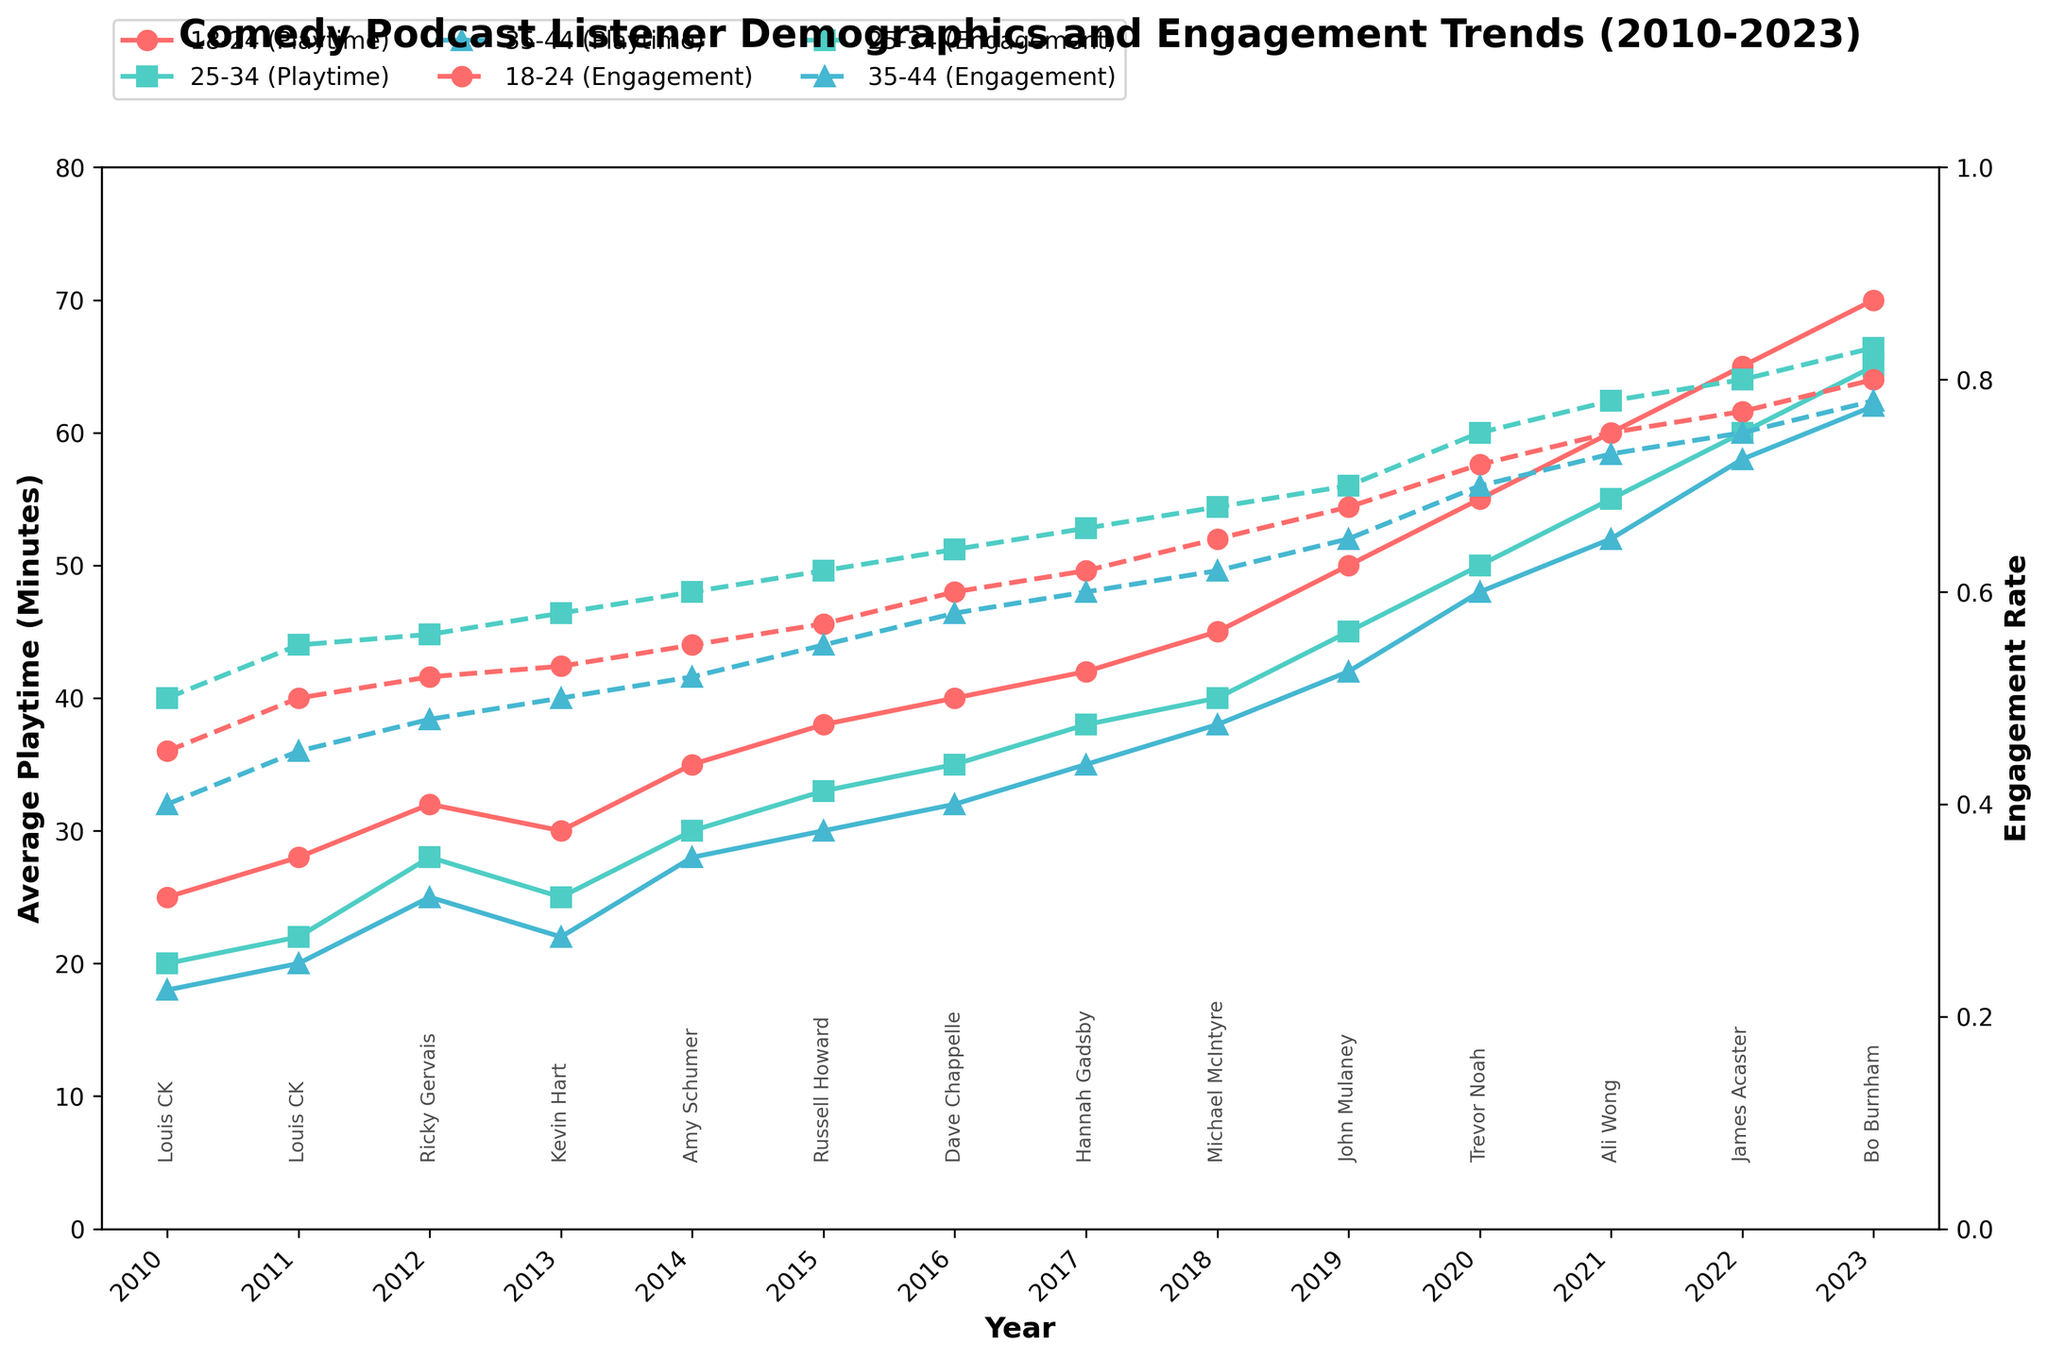What is the average playtime for the 18-24 age group in 2012? Refer to the plot and find the point corresponding to the 18-24 age group for the year 2012, which shows the average playtime as 32 minutes.
Answer: 32 minutes What is the title of the figure? The figure's title is displayed at the top center, which reads "Comedy Podcast Listener Demographics and Engagement Trends (2010-2023)".
Answer: Comedy Podcast Listener Demographics and Engagement Trends (2010-2023) Which age group had the highest engagement rate in 2020 and what was the rate? Look at the dashed lines for the year 2020. The age group with the highest engagement rate is 25-34, and the engagement rate was 0.75.
Answer: 25-34 with 0.75 What is the trend for average playtime for the 18-24 age group from 2010 to 2023? Follow the solid line and circular markers for the 18-24 age group from 2010 to 2023. The average playtime for this age group shows an increasing trend over the years.
Answer: Increasing trend Compare the engagement rate between the 25-34 and 35-44 age groups in 2021. Which age group has a higher rate, and by how much? Look at the dashed lines for both age groups in 2021. The engagement rate for the 25-34 age group is 0.78, and for the 35-44 age group, it is 0.73. The difference is 0.78 - 0.73 = 0.05.
Answer: 25-34 by 0.05 Which year had the highest average playtime for the 35-44 age group, and what was it? Examine the solid lines and triangular markers for the 35-44 age group across all years. The highest point is in 2023, with an average playtime of 62 minutes.
Answer: 2023 with 62 minutes What was the top comedian in 2019? Look at the annotated text near 2019 on the x-axis. The top comedian for 2019 is John Mulaney.
Answer: John Mulaney Calculate the average engagement rate for the 25-34 age group over the entire period. Identify the engagement rate for the 25-34 age group from 2010 to 2023 and sum these values: 0.50, 0.55, 0.56, 0.58, 0.60, 0.62, 0.64, 0.66, 0.68, 0.70, 0.75, 0.78, 0.80, 0.83. The sum is 8.46. There are 14 data points, so the average is 8.46 / 14 ≈ 0.60.
Answer: ≈ 0.60 Was there any year when the engagement rate for the 18-24 age group dipped from the previous year? If yes, which year? Follow the dashed line for the 18-24 age group and observe if there is any drop between consecutive points. The engagement rate dipped from 0.53 in 2013 to 0.55 in 2014.
Answer: No 